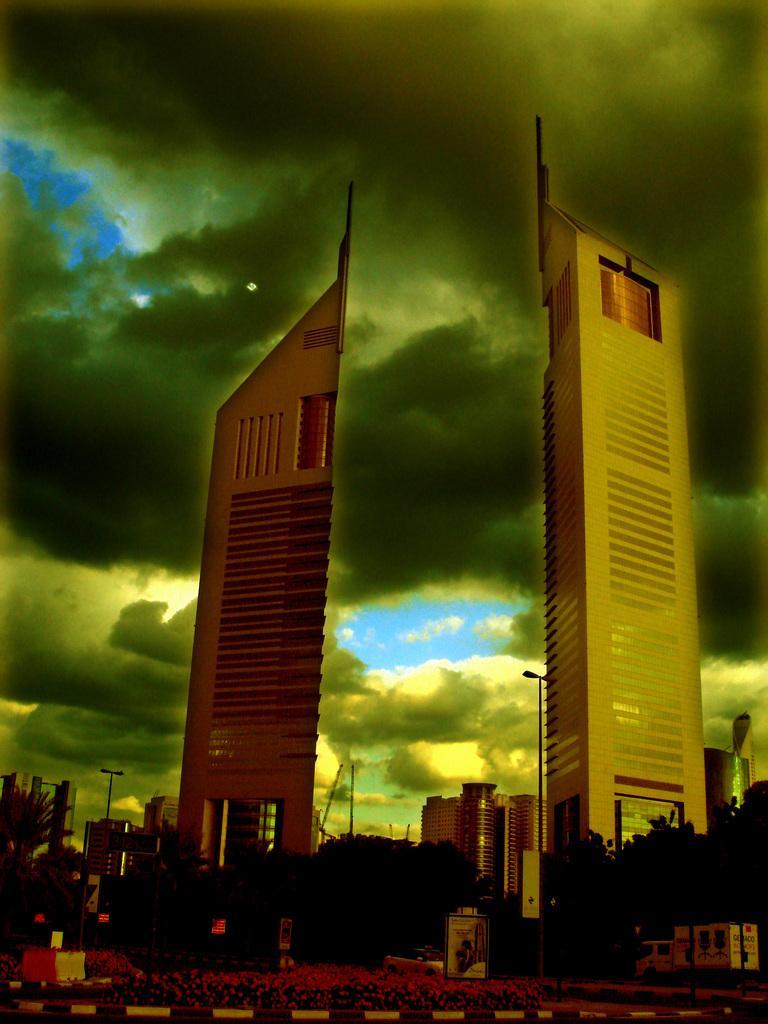How would you summarize this image in a sentence or two? In this image there are some buildings, trees, poles, street lights, skyscrapers are there in the center. At the bottom there are some plants and pavement and vehicle, at the top there is sky. 